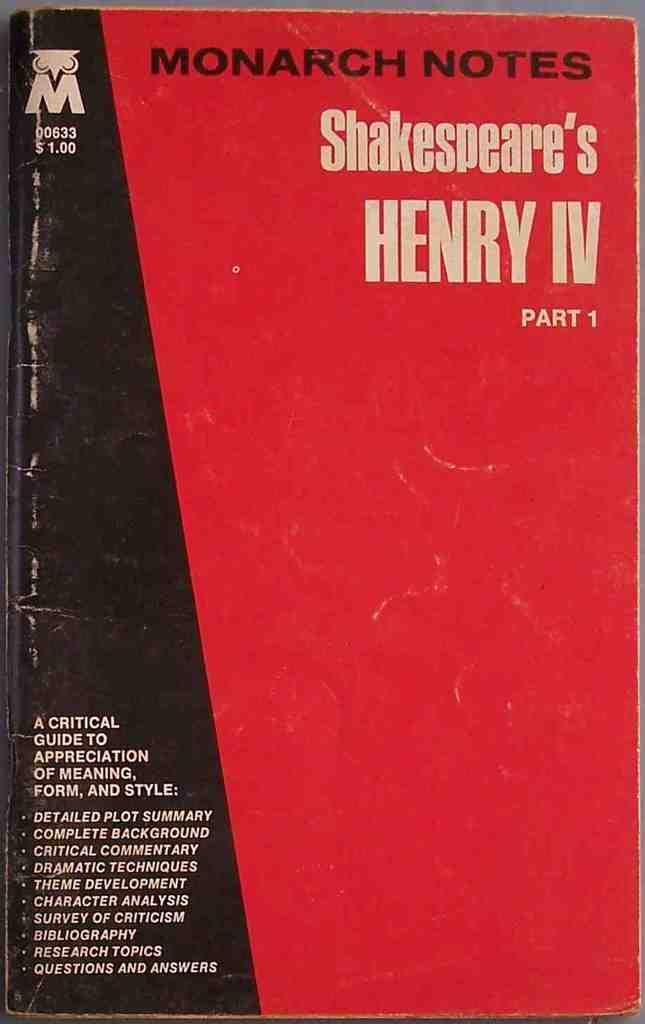Could you describe the condition of this book and what it suggests about its usage? The book shows signs of considerable wear, particularly along the spine and edges, suggesting it has been frequently used, likely by a student or a researcher deeply engaged with Shakespeare's work.  What does the red color on the book cover signify? The red color on the book cover might be designed to grab attention and signify passion, a theme prevalent in many of Shakespeare's plays, including Henry IV. 